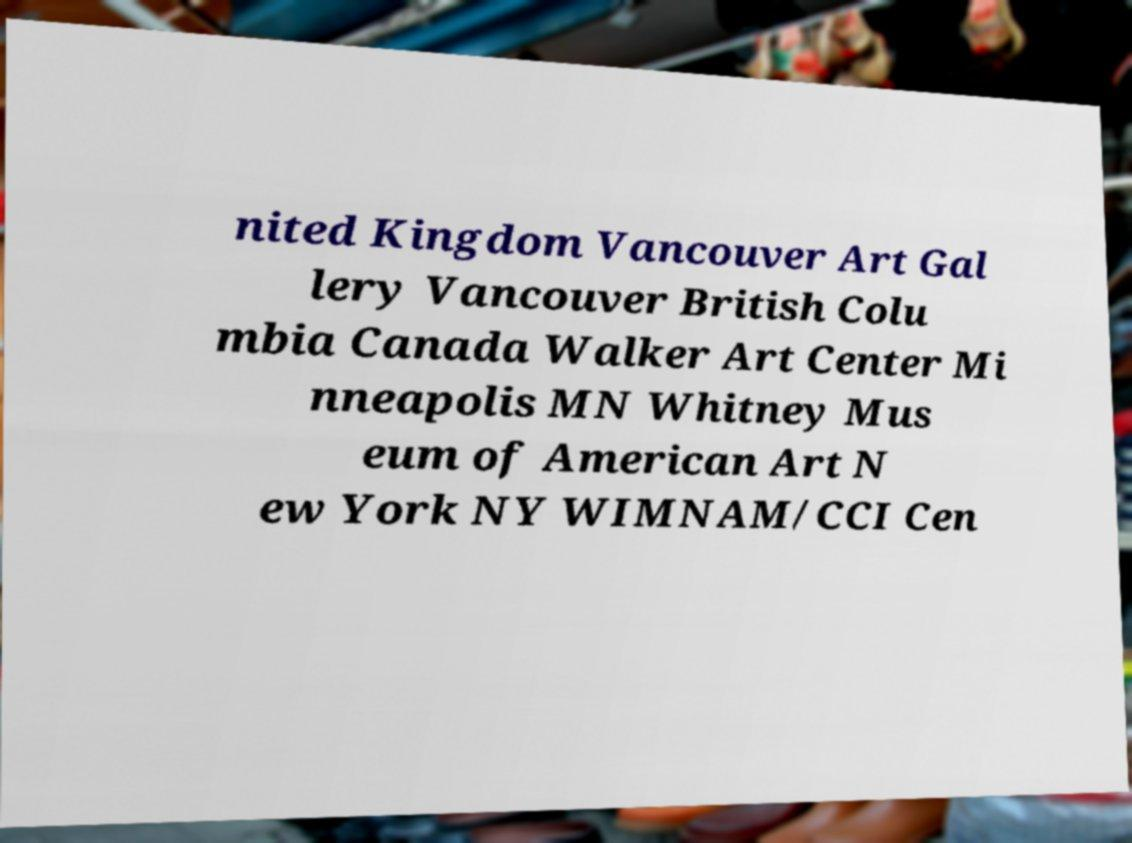Can you read and provide the text displayed in the image?This photo seems to have some interesting text. Can you extract and type it out for me? nited Kingdom Vancouver Art Gal lery Vancouver British Colu mbia Canada Walker Art Center Mi nneapolis MN Whitney Mus eum of American Art N ew York NY WIMNAM/CCI Cen 